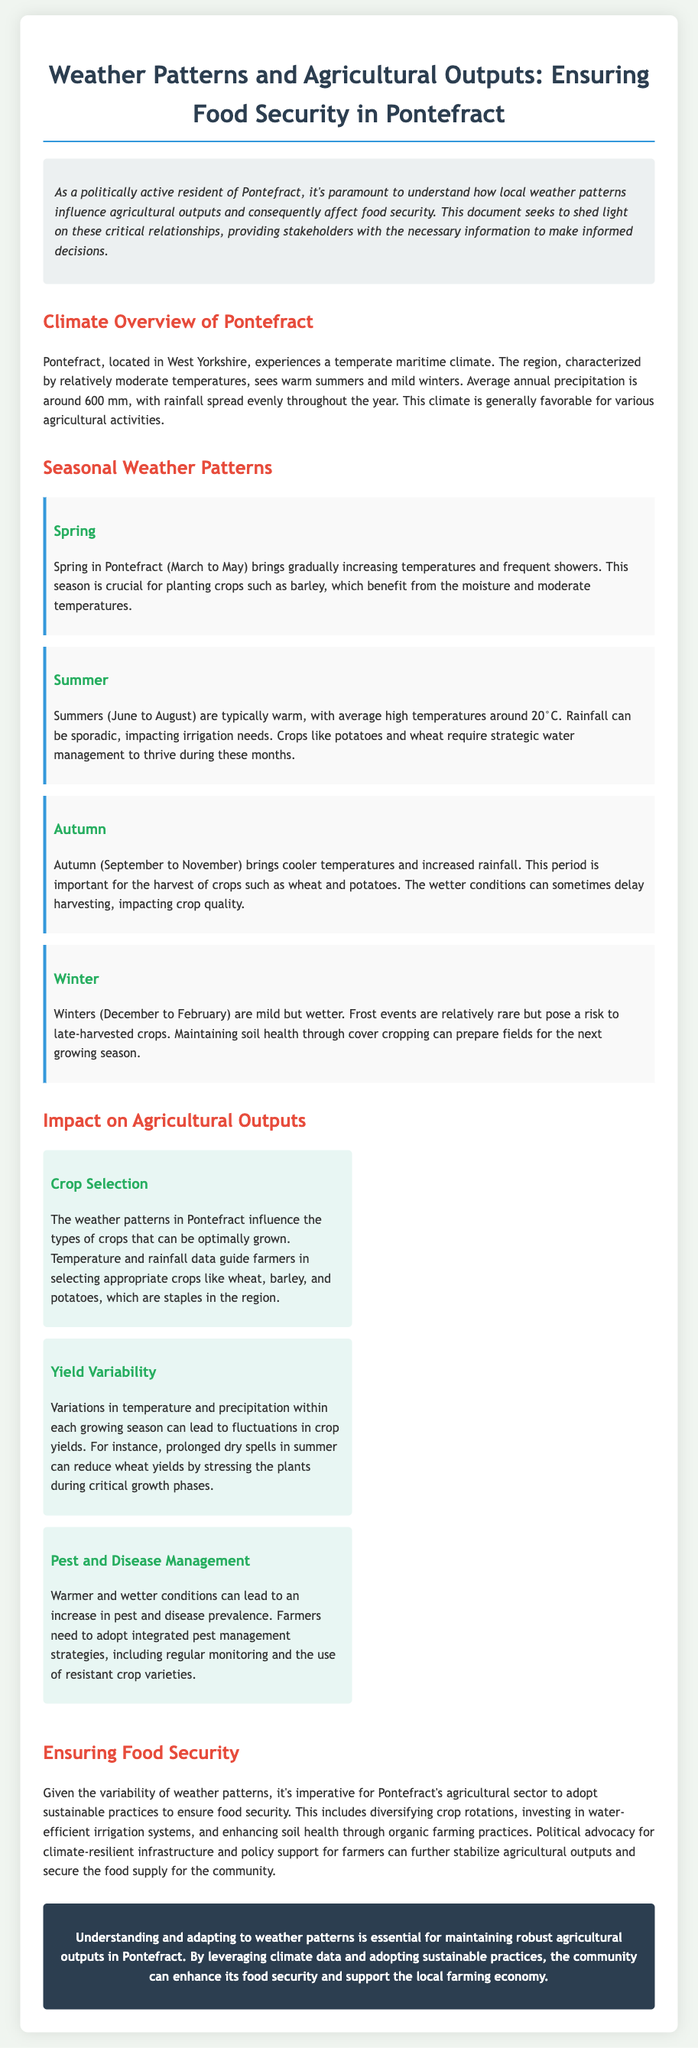What is the average annual precipitation in Pontefract? The document states that the average annual precipitation is around 600 mm.
Answer: 600 mm Which crops are mentioned as staples in Pontefract? The document lists wheat, barley, and potatoes as staple crops grown in the region.
Answer: wheat, barley, and potatoes What season is crucial for planting barley? The document indicates that spring is crucial for planting barley.
Answer: spring What is the average high temperature during summer in Pontefract? The document provides that the average high temperatures during summer are around 20°C.
Answer: 20°C How can increased rainfall in autumn affect harvesting? According to the document, increased rainfall can sometimes delay harvesting, impacting crop quality.
Answer: delay harvesting What practice is suggested for maintaining soil health during winter? The document suggests maintaining soil health through cover cropping.
Answer: cover cropping Which weather condition can stress wheat plants during summer? The document mentions that prolonged dry spells can stress wheat plants during critical growth phases.
Answer: prolonged dry spells What approach is recommended for pest management? The document advises adopting integrated pest management strategies, including regular monitoring.
Answer: integrated pest management strategies 